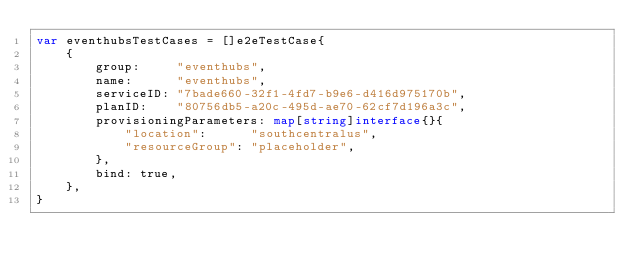<code> <loc_0><loc_0><loc_500><loc_500><_Go_>var eventhubsTestCases = []e2eTestCase{
	{
		group:     "eventhubs",
		name:      "eventhubs",
		serviceID: "7bade660-32f1-4fd7-b9e6-d416d975170b",
		planID:    "80756db5-a20c-495d-ae70-62cf7d196a3c",
		provisioningParameters: map[string]interface{}{
			"location":      "southcentralus",
			"resourceGroup": "placeholder",
		},
		bind: true,
	},
}
</code> 